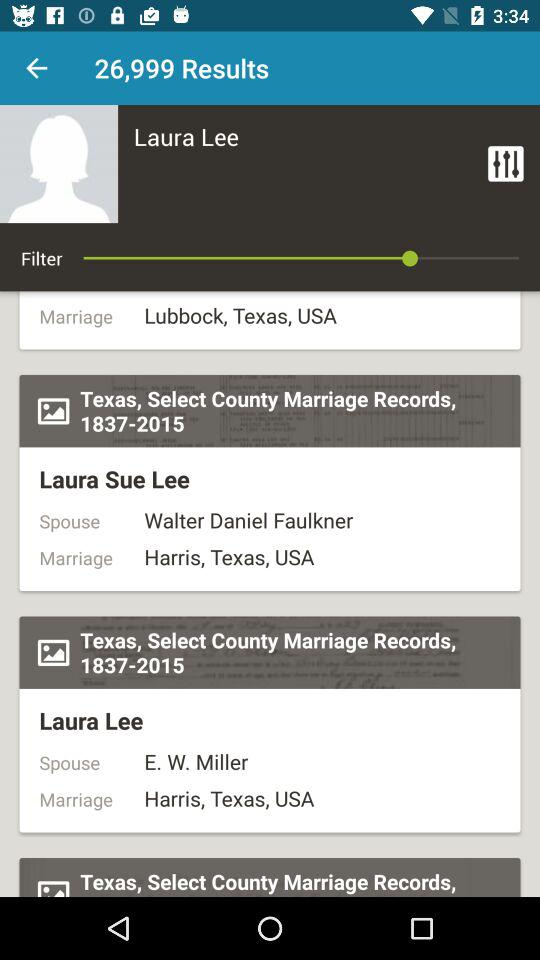What is the marriage location of Laura Lee? The location is Harris, Texas, USA. 